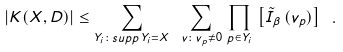Convert formula to latex. <formula><loc_0><loc_0><loc_500><loc_500>| K ( X , D ) | \leq \sum _ { Y _ { i } \colon s u p p \, Y _ { i } = X } \ \sum _ { v \colon v _ { p } \neq 0 } \, \prod _ { p \in Y _ { i } } \, \left [ \tilde { I } _ { \beta } \, ( v _ { p } ) \right ] \ .</formula> 